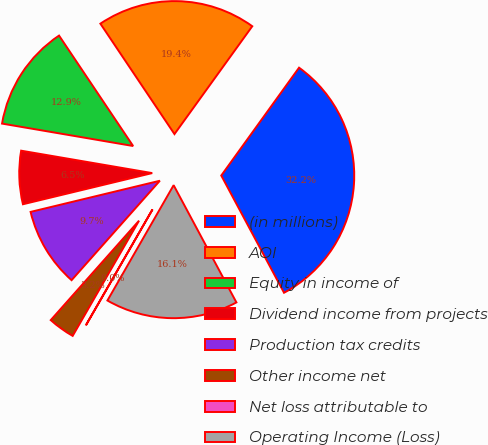Convert chart to OTSL. <chart><loc_0><loc_0><loc_500><loc_500><pie_chart><fcel>(in millions)<fcel>AOI<fcel>Equity in income of<fcel>Dividend income from projects<fcel>Production tax credits<fcel>Other income net<fcel>Net loss attributable to<fcel>Operating Income (Loss)<nl><fcel>32.23%<fcel>19.35%<fcel>12.9%<fcel>6.46%<fcel>9.68%<fcel>3.24%<fcel>0.02%<fcel>16.12%<nl></chart> 